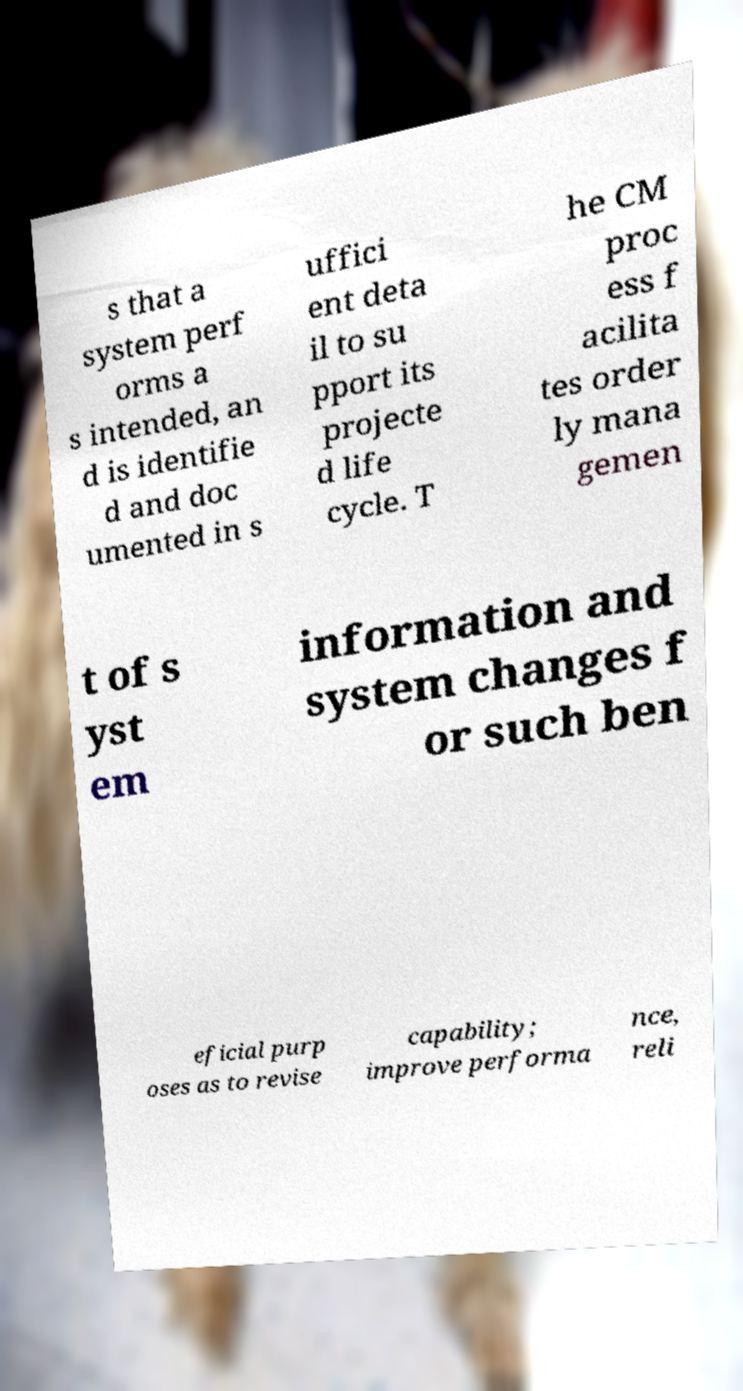I need the written content from this picture converted into text. Can you do that? s that a system perf orms a s intended, an d is identifie d and doc umented in s uffici ent deta il to su pport its projecte d life cycle. T he CM proc ess f acilita tes order ly mana gemen t of s yst em information and system changes f or such ben eficial purp oses as to revise capability; improve performa nce, reli 